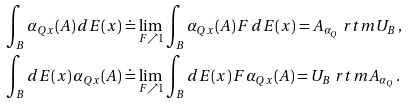<formula> <loc_0><loc_0><loc_500><loc_500>& \int _ { B } \alpha _ { Q x } ( A ) \, d E ( x ) \doteq \lim _ { F \nearrow 1 } \int _ { B } \alpha _ { Q x } ( A ) \, F \, d E ( x ) = A _ { \alpha _ { Q } } \ r t m U _ { B } \, , \\ & \int _ { B } d E ( x ) \, \alpha _ { Q x } ( A ) \doteq \lim _ { F \nearrow 1 } \int _ { B } d E ( x ) \, F \alpha _ { Q x } ( A ) = U _ { B } \ r t m A _ { \alpha _ { Q } } \, .</formula> 